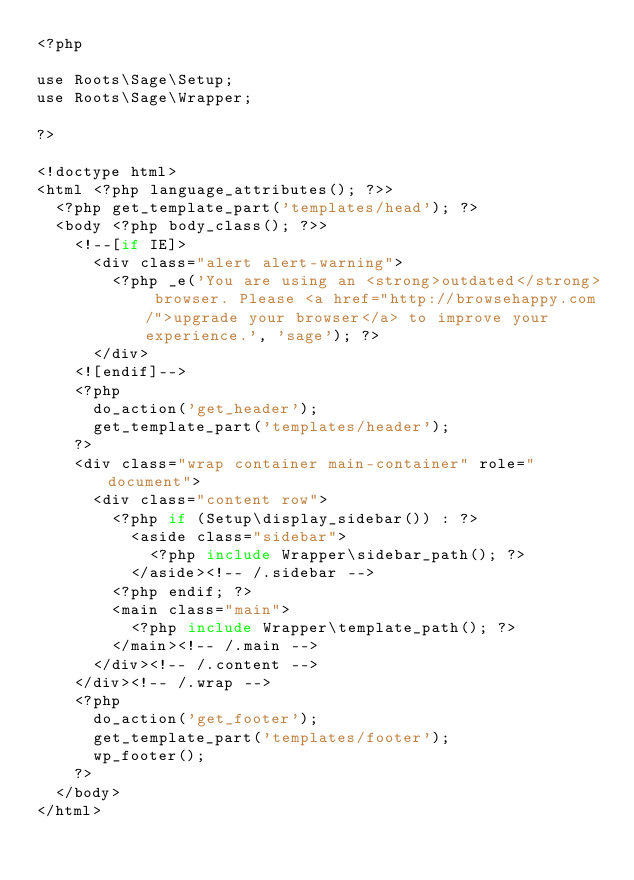<code> <loc_0><loc_0><loc_500><loc_500><_PHP_><?php

use Roots\Sage\Setup;
use Roots\Sage\Wrapper;

?>

<!doctype html>
<html <?php language_attributes(); ?>>
  <?php get_template_part('templates/head'); ?>
  <body <?php body_class(); ?>>
    <!--[if IE]>
      <div class="alert alert-warning">
        <?php _e('You are using an <strong>outdated</strong> browser. Please <a href="http://browsehappy.com/">upgrade your browser</a> to improve your experience.', 'sage'); ?>
      </div>
    <![endif]-->
    <?php
      do_action('get_header');
      get_template_part('templates/header');
    ?>
    <div class="wrap container main-container" role="document">
      <div class="content row">
        <?php if (Setup\display_sidebar()) : ?>
          <aside class="sidebar">
            <?php include Wrapper\sidebar_path(); ?>
          </aside><!-- /.sidebar -->
        <?php endif; ?>
        <main class="main">
          <?php include Wrapper\template_path(); ?>
        </main><!-- /.main -->
      </div><!-- /.content -->
    </div><!-- /.wrap -->
    <?php
      do_action('get_footer');
      get_template_part('templates/footer');
      wp_footer();
    ?>
  </body>
</html>
</code> 